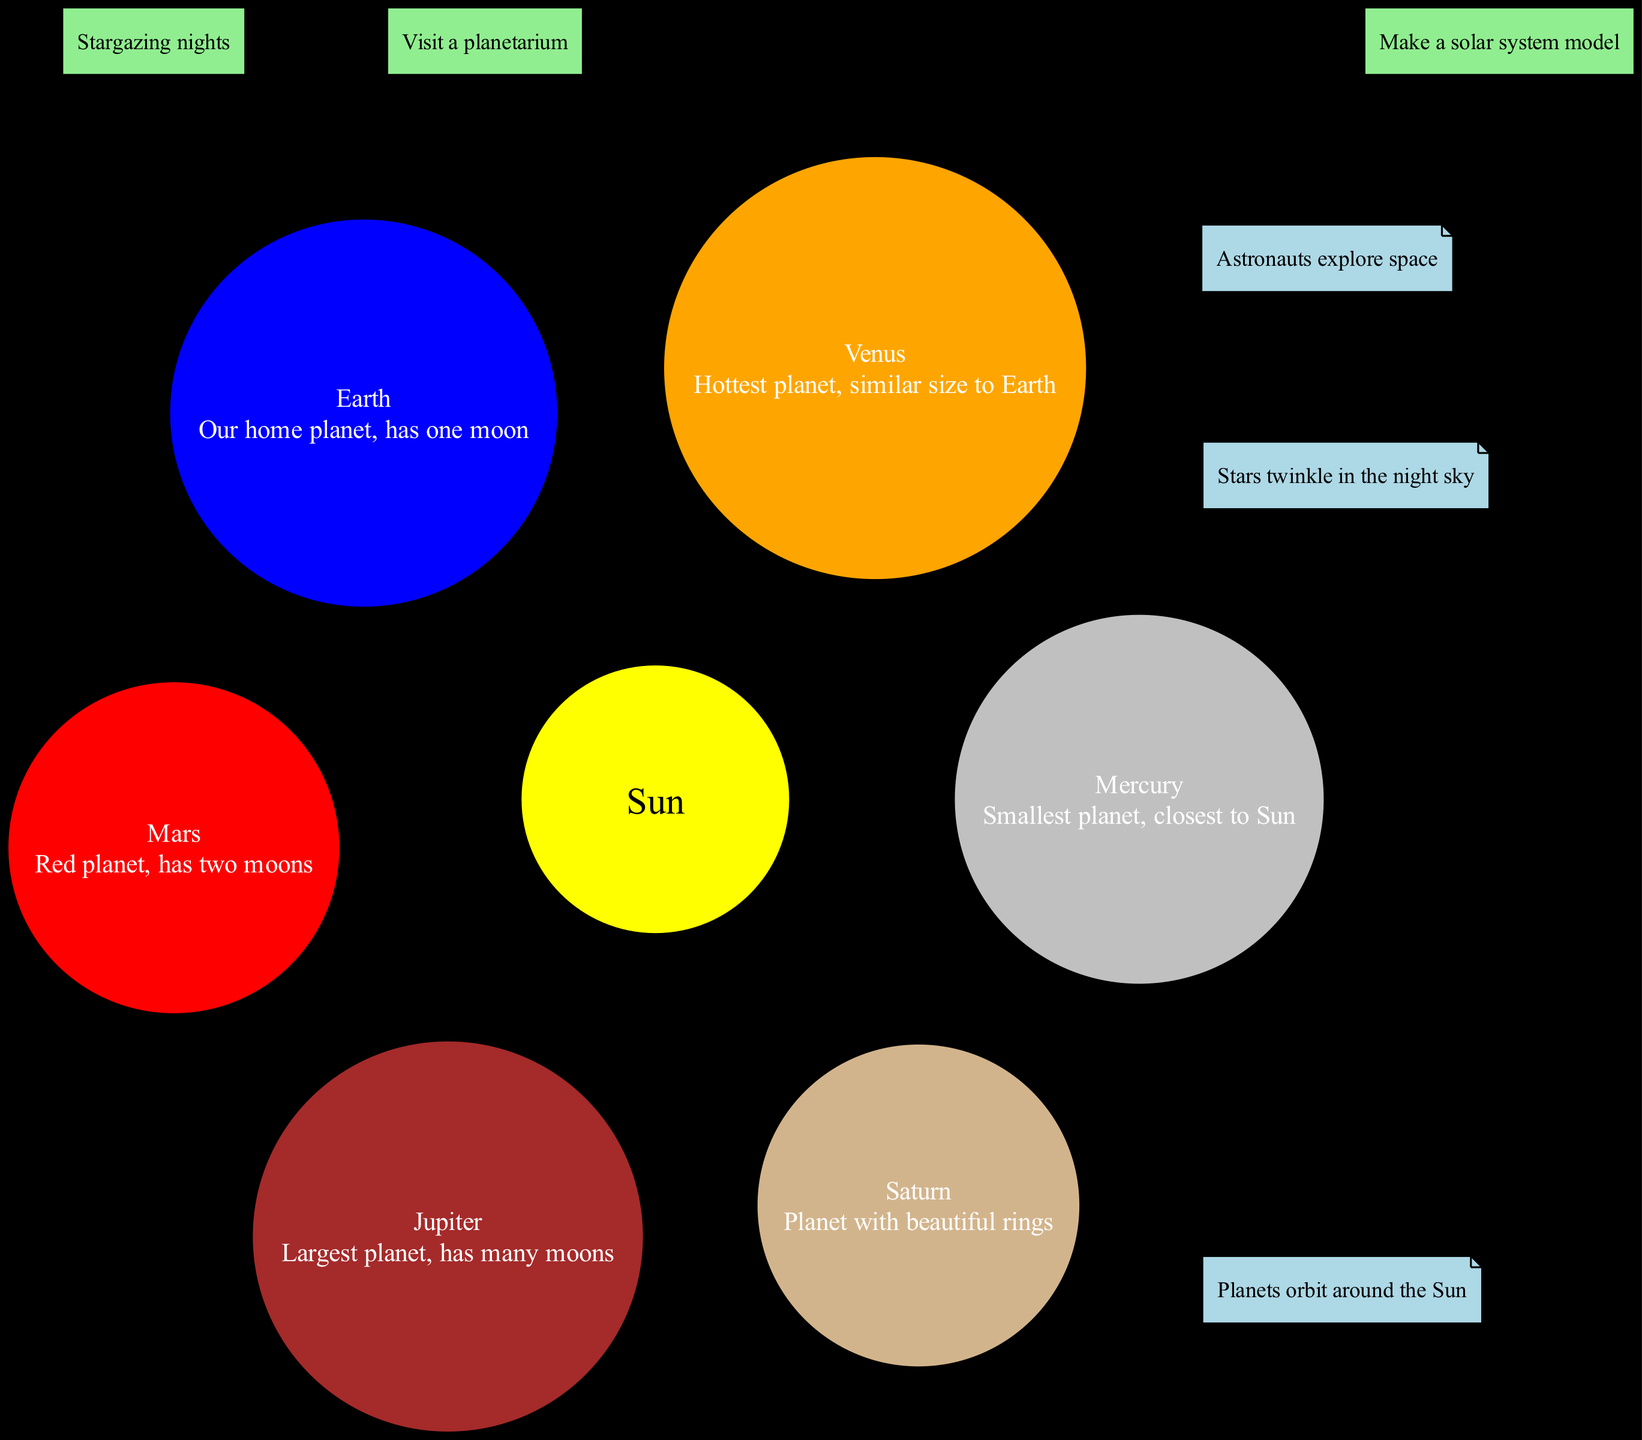What is the center of the solar system? The diagram shows that the Sun is the center of the solar system, as indicated by its central position and description.
Answer: Sun Which planet is the hottest? The diagram labels Venus as the hottest planet, which is found among the list of planets and is explicitly described as such.
Answer: Venus How many moons does Earth have? The diagram states that Earth has one moon in its description, so counting is not necessary; it's explicitly mentioned.
Answer: one Which planet is the largest? The diagram describes Jupiter as the largest planet, making it directly clear without needing to compare sizes visually.
Answer: Jupiter How many planets are there in total? By counting the listed planets in the diagram, we can see there are six planets shown surrounding the Sun.
Answer: six What color is Saturn illustrated in? The diagram depicts Saturn in a tan color, as indicated by its representation among the planets and directly inferred from the filling colors.
Answer: tan Which family activity involves watching the stars? The diagram lists "Stargazing nights" as one of the family activities, which is particularly focused on observing the stars.
Answer: Stargazing nights What are the fun facts related to the solar system? The diagram lists several fun facts; it specifically mentions that "Planets orbit around the Sun." The other facts are also present but need to be selected based on what's asked.
Answer: Planets orbit around the Sun How many moons does Mars have? The diagram indicates that Mars has two moons as stated in its specific description, allowing us to simply extract that from what is provided.
Answer: two 